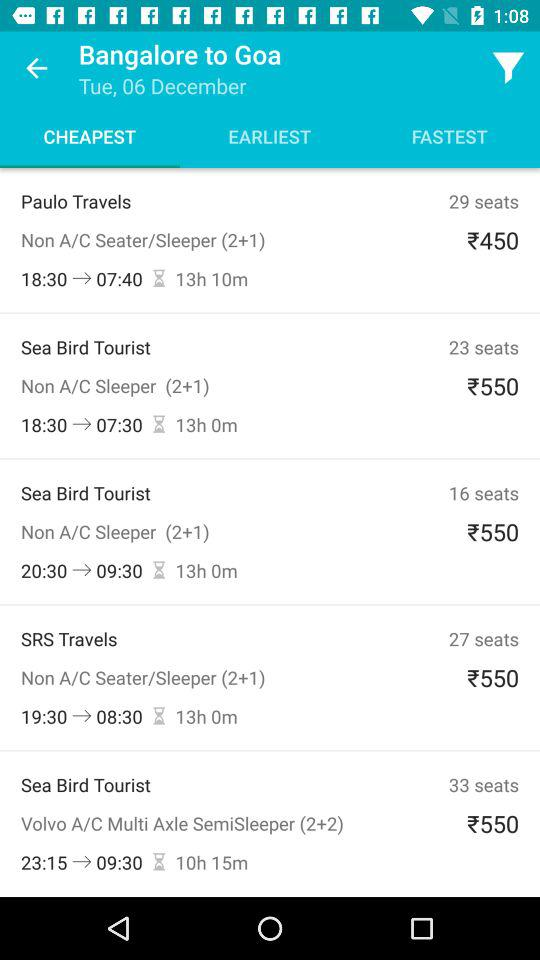How many seats does the cheapest option have?
Answer the question using a single word or phrase. 29 